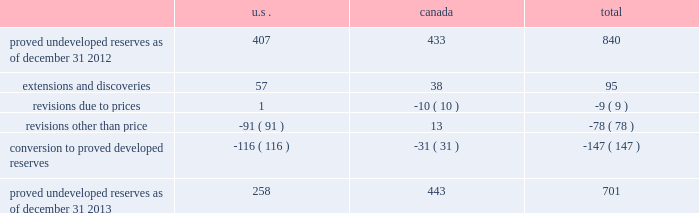Devon energy corporation and subsidiaries notes to consolidated financial statements 2013 ( continued ) proved undeveloped reserves the table presents the changes in devon 2019s total proved undeveloped reserves during 2013 ( in mmboe ) . .
At december 31 , 2013 , devon had 701 mmboe of proved undeveloped reserves .
This represents a 17 percent decrease as compared to 2012 and represents 24 percent of total proved reserves .
Drilling and development activities increased devon 2019s proved undeveloped reserves 95 mmboe and resulted in the conversion of 147 mmboe , or 18 percent , of the 2012 proved undeveloped reserves to proved developed reserves .
Costs incurred related to the development and conversion of devon 2019s proved undeveloped reserves were $ 1.9 billion for 2013 .
Additionally , revisions other than price decreased devon 2019s proved undeveloped reserves 78 mmboe primarily due to evaluations of certain u.s .
Onshore dry-gas areas , which devon does not expect to develop in the next five years .
The largest revisions relate to the dry-gas areas in the cana-woodford shale in western oklahoma , carthage in east texas and the barnett shale in north texas .
A significant amount of devon 2019s proved undeveloped reserves at the end of 2013 related to its jackfish operations .
At december 31 , 2013 and 2012 , devon 2019s jackfish proved undeveloped reserves were 441 mmboe and 429 mmboe , respectively .
Development schedules for the jackfish reserves are primarily controlled by the need to keep the processing plants at their 35000 barrel daily facility capacity .
Processing plant capacity is controlled by factors such as total steam processing capacity , steam-oil ratios and air quality discharge permits .
As a result , these reserves are classified as proved undeveloped for more than five years .
Currently , the development schedule for these reserves extends though the year 2031 .
Price revisions 2013 2013 reserves increased 94 mmboe primarily due to higher gas prices .
Of this increase , 43 mmboe related to the barnett shale and 19 mmboe related to the rocky mountain area .
2012 2013 reserves decreased 171 mmboe primarily due to lower gas prices .
Of this decrease , 100 mmboe related to the barnett shale and 25 mmboe related to the rocky mountain area .
2011 2013 reserves decreased 21 mmboe due to lower gas prices and higher oil prices .
The higher oil prices increased devon 2019s canadian royalty burden , which reduced devon 2019s oil reserves .
Revisions other than price total revisions other than price for 2013 , 2012 and 2011 primarily related to devon 2019s evaluation of certain dry gas regions , with the largest revisions being made in the cana-woodford shale , barnett shale and carthage .
What percentage of total revisions were not related to prices? 
Computations: ((78 / (9 + 78)) * 100)
Answer: 89.65517. 